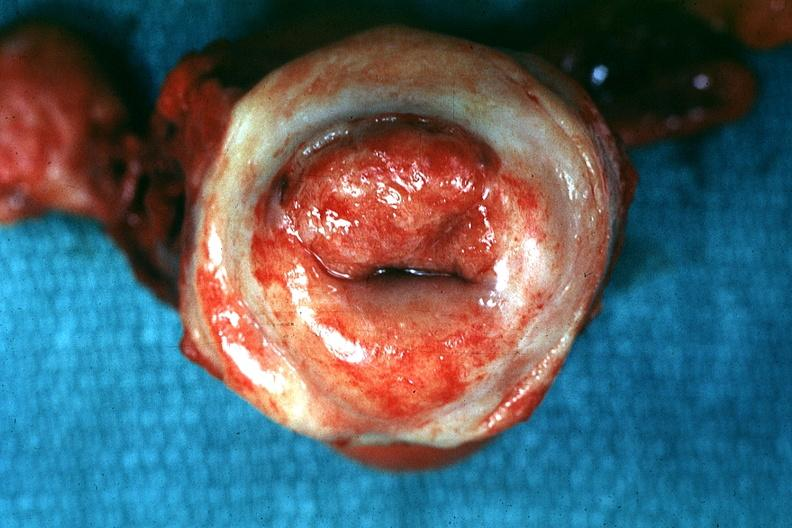s slide present?
Answer the question using a single word or phrase. No 